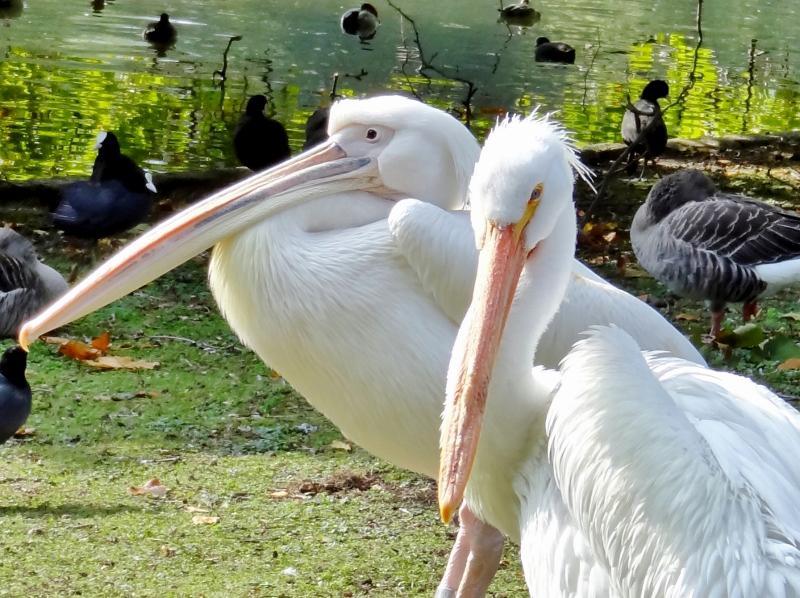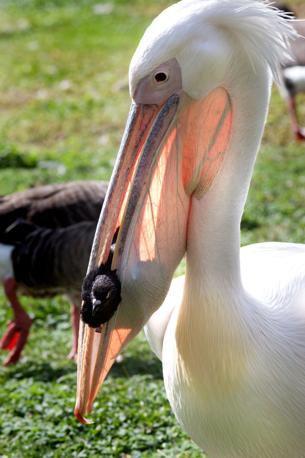The first image is the image on the left, the second image is the image on the right. Assess this claim about the two images: "In one image, a pelican's beak is open wide so the inside can be seen, while in the other image, a pelican has an animal caught in its beak.". Correct or not? Answer yes or no. No. 